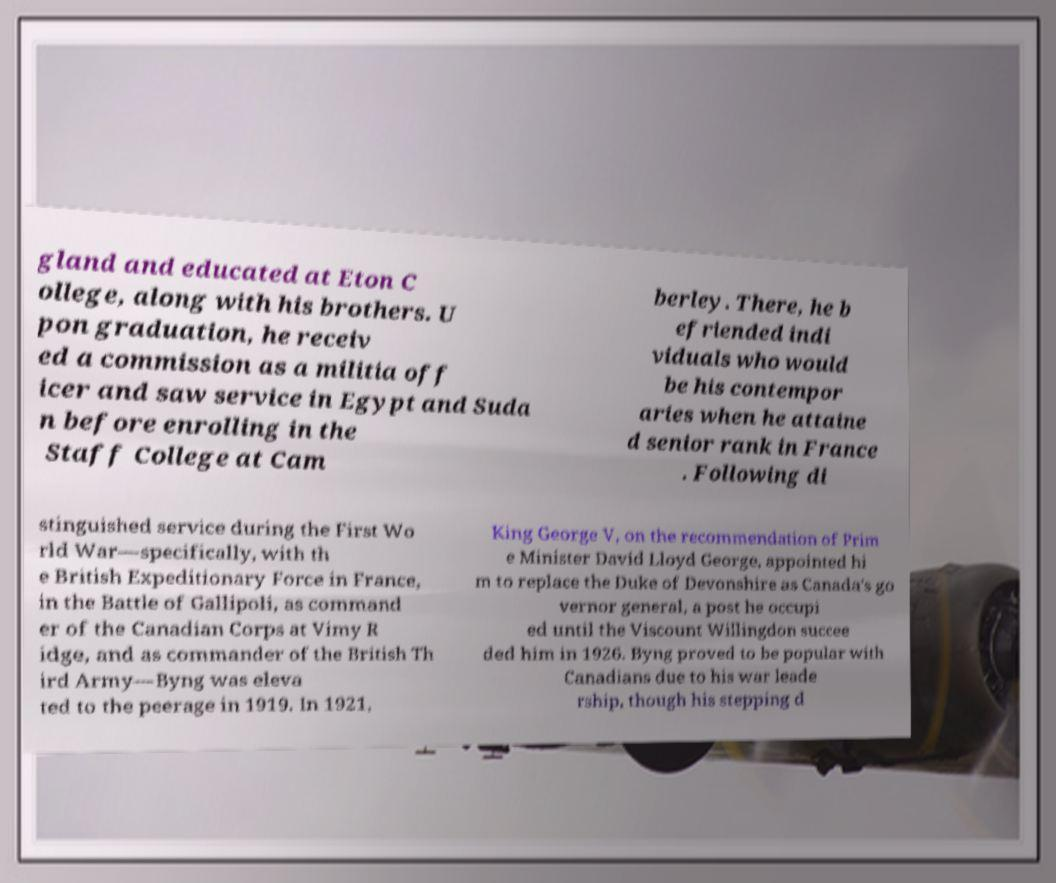I need the written content from this picture converted into text. Can you do that? gland and educated at Eton C ollege, along with his brothers. U pon graduation, he receiv ed a commission as a militia off icer and saw service in Egypt and Suda n before enrolling in the Staff College at Cam berley. There, he b efriended indi viduals who would be his contempor aries when he attaine d senior rank in France . Following di stinguished service during the First Wo rld War—specifically, with th e British Expeditionary Force in France, in the Battle of Gallipoli, as command er of the Canadian Corps at Vimy R idge, and as commander of the British Th ird Army—Byng was eleva ted to the peerage in 1919. In 1921, King George V, on the recommendation of Prim e Minister David Lloyd George, appointed hi m to replace the Duke of Devonshire as Canada's go vernor general, a post he occupi ed until the Viscount Willingdon succee ded him in 1926. Byng proved to be popular with Canadians due to his war leade rship, though his stepping d 